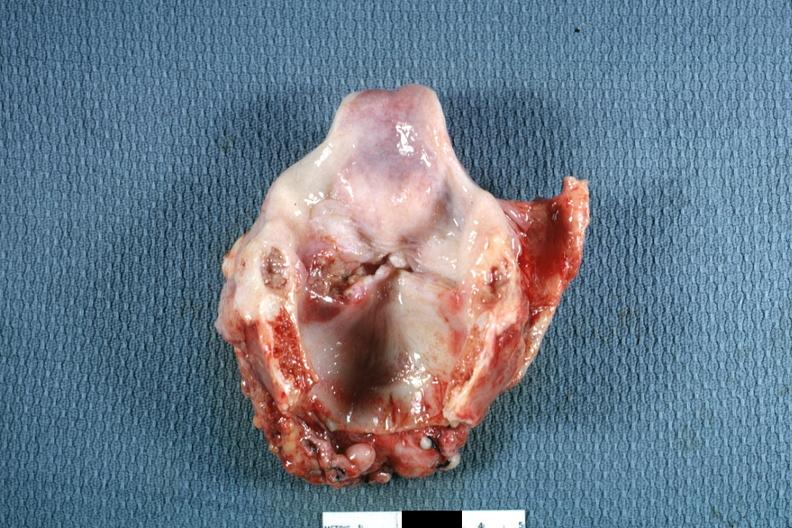s larynx present?
Answer the question using a single word or phrase. Yes 